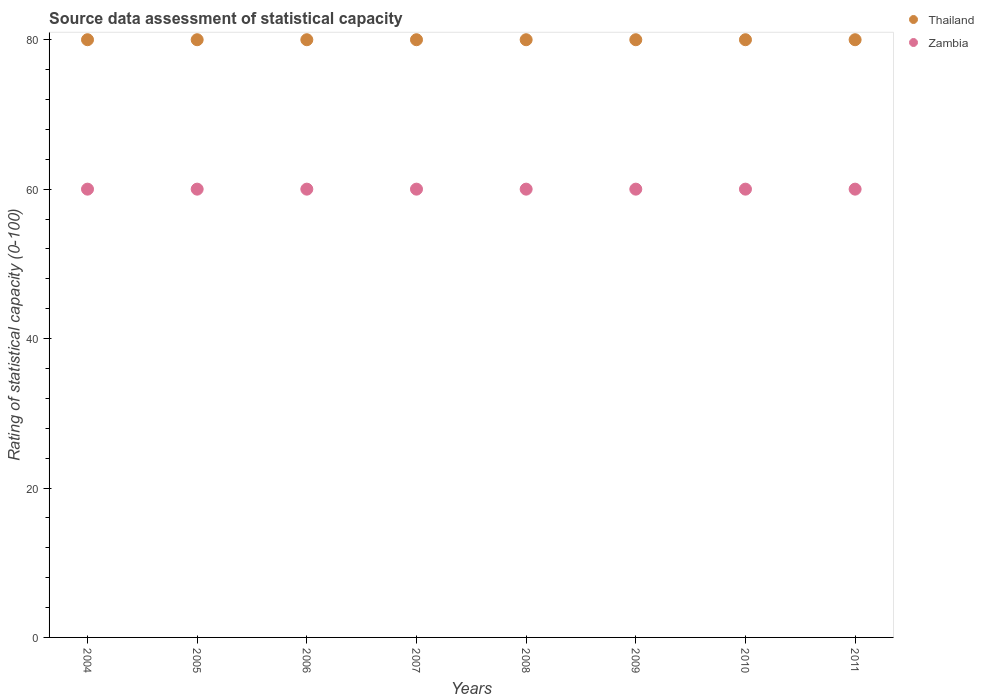Is the number of dotlines equal to the number of legend labels?
Keep it short and to the point. Yes. What is the rating of statistical capacity in Zambia in 2006?
Your answer should be compact. 60. Across all years, what is the maximum rating of statistical capacity in Thailand?
Your response must be concise. 80. Across all years, what is the minimum rating of statistical capacity in Thailand?
Your answer should be very brief. 80. What is the total rating of statistical capacity in Thailand in the graph?
Provide a succinct answer. 640. What is the difference between the rating of statistical capacity in Thailand in 2004 and the rating of statistical capacity in Zambia in 2008?
Ensure brevity in your answer.  20. In the year 2011, what is the difference between the rating of statistical capacity in Thailand and rating of statistical capacity in Zambia?
Provide a succinct answer. 20. Is the difference between the rating of statistical capacity in Thailand in 2009 and 2010 greater than the difference between the rating of statistical capacity in Zambia in 2009 and 2010?
Make the answer very short. No. Is the rating of statistical capacity in Zambia strictly greater than the rating of statistical capacity in Thailand over the years?
Your answer should be very brief. No. How many years are there in the graph?
Your answer should be very brief. 8. What is the difference between two consecutive major ticks on the Y-axis?
Keep it short and to the point. 20. Does the graph contain grids?
Your answer should be very brief. No. How are the legend labels stacked?
Your answer should be compact. Vertical. What is the title of the graph?
Provide a short and direct response. Source data assessment of statistical capacity. Does "Sub-Saharan Africa (developing only)" appear as one of the legend labels in the graph?
Keep it short and to the point. No. What is the label or title of the X-axis?
Make the answer very short. Years. What is the label or title of the Y-axis?
Make the answer very short. Rating of statistical capacity (0-100). What is the Rating of statistical capacity (0-100) in Zambia in 2005?
Your response must be concise. 60. What is the Rating of statistical capacity (0-100) in Zambia in 2007?
Ensure brevity in your answer.  60. What is the Rating of statistical capacity (0-100) in Thailand in 2009?
Your answer should be compact. 80. What is the Rating of statistical capacity (0-100) of Thailand in 2010?
Give a very brief answer. 80. What is the Rating of statistical capacity (0-100) in Zambia in 2010?
Keep it short and to the point. 60. Across all years, what is the maximum Rating of statistical capacity (0-100) of Zambia?
Give a very brief answer. 60. Across all years, what is the minimum Rating of statistical capacity (0-100) of Thailand?
Your answer should be very brief. 80. Across all years, what is the minimum Rating of statistical capacity (0-100) of Zambia?
Offer a terse response. 60. What is the total Rating of statistical capacity (0-100) in Thailand in the graph?
Provide a succinct answer. 640. What is the total Rating of statistical capacity (0-100) in Zambia in the graph?
Give a very brief answer. 480. What is the difference between the Rating of statistical capacity (0-100) of Thailand in 2004 and that in 2005?
Your answer should be very brief. 0. What is the difference between the Rating of statistical capacity (0-100) in Thailand in 2004 and that in 2006?
Your answer should be compact. 0. What is the difference between the Rating of statistical capacity (0-100) in Zambia in 2004 and that in 2006?
Provide a succinct answer. 0. What is the difference between the Rating of statistical capacity (0-100) in Thailand in 2004 and that in 2007?
Make the answer very short. 0. What is the difference between the Rating of statistical capacity (0-100) in Zambia in 2004 and that in 2007?
Offer a very short reply. 0. What is the difference between the Rating of statistical capacity (0-100) of Zambia in 2004 and that in 2008?
Provide a succinct answer. 0. What is the difference between the Rating of statistical capacity (0-100) in Thailand in 2004 and that in 2011?
Provide a short and direct response. 0. What is the difference between the Rating of statistical capacity (0-100) of Zambia in 2005 and that in 2007?
Your answer should be very brief. 0. What is the difference between the Rating of statistical capacity (0-100) in Zambia in 2005 and that in 2008?
Your answer should be compact. 0. What is the difference between the Rating of statistical capacity (0-100) in Thailand in 2005 and that in 2009?
Keep it short and to the point. 0. What is the difference between the Rating of statistical capacity (0-100) of Zambia in 2005 and that in 2010?
Offer a terse response. 0. What is the difference between the Rating of statistical capacity (0-100) of Thailand in 2006 and that in 2007?
Give a very brief answer. 0. What is the difference between the Rating of statistical capacity (0-100) of Zambia in 2006 and that in 2007?
Make the answer very short. 0. What is the difference between the Rating of statistical capacity (0-100) of Thailand in 2006 and that in 2008?
Give a very brief answer. 0. What is the difference between the Rating of statistical capacity (0-100) of Zambia in 2006 and that in 2008?
Your answer should be very brief. 0. What is the difference between the Rating of statistical capacity (0-100) of Thailand in 2006 and that in 2010?
Your answer should be compact. 0. What is the difference between the Rating of statistical capacity (0-100) of Zambia in 2006 and that in 2010?
Offer a terse response. 0. What is the difference between the Rating of statistical capacity (0-100) of Zambia in 2006 and that in 2011?
Ensure brevity in your answer.  0. What is the difference between the Rating of statistical capacity (0-100) of Thailand in 2007 and that in 2008?
Your answer should be very brief. 0. What is the difference between the Rating of statistical capacity (0-100) of Thailand in 2007 and that in 2009?
Your response must be concise. 0. What is the difference between the Rating of statistical capacity (0-100) of Thailand in 2007 and that in 2010?
Provide a short and direct response. 0. What is the difference between the Rating of statistical capacity (0-100) in Zambia in 2007 and that in 2010?
Provide a short and direct response. 0. What is the difference between the Rating of statistical capacity (0-100) of Thailand in 2008 and that in 2009?
Offer a terse response. 0. What is the difference between the Rating of statistical capacity (0-100) of Thailand in 2010 and that in 2011?
Provide a succinct answer. 0. What is the difference between the Rating of statistical capacity (0-100) in Zambia in 2010 and that in 2011?
Give a very brief answer. 0. What is the difference between the Rating of statistical capacity (0-100) in Thailand in 2004 and the Rating of statistical capacity (0-100) in Zambia in 2009?
Give a very brief answer. 20. What is the difference between the Rating of statistical capacity (0-100) of Thailand in 2004 and the Rating of statistical capacity (0-100) of Zambia in 2011?
Offer a very short reply. 20. What is the difference between the Rating of statistical capacity (0-100) of Thailand in 2005 and the Rating of statistical capacity (0-100) of Zambia in 2007?
Make the answer very short. 20. What is the difference between the Rating of statistical capacity (0-100) in Thailand in 2005 and the Rating of statistical capacity (0-100) in Zambia in 2009?
Keep it short and to the point. 20. What is the difference between the Rating of statistical capacity (0-100) in Thailand in 2005 and the Rating of statistical capacity (0-100) in Zambia in 2010?
Offer a terse response. 20. What is the difference between the Rating of statistical capacity (0-100) in Thailand in 2005 and the Rating of statistical capacity (0-100) in Zambia in 2011?
Provide a short and direct response. 20. What is the difference between the Rating of statistical capacity (0-100) in Thailand in 2007 and the Rating of statistical capacity (0-100) in Zambia in 2010?
Offer a very short reply. 20. What is the difference between the Rating of statistical capacity (0-100) of Thailand in 2007 and the Rating of statistical capacity (0-100) of Zambia in 2011?
Offer a terse response. 20. What is the difference between the Rating of statistical capacity (0-100) of Thailand in 2008 and the Rating of statistical capacity (0-100) of Zambia in 2010?
Give a very brief answer. 20. What is the difference between the Rating of statistical capacity (0-100) of Thailand in 2008 and the Rating of statistical capacity (0-100) of Zambia in 2011?
Your answer should be very brief. 20. What is the difference between the Rating of statistical capacity (0-100) of Thailand in 2009 and the Rating of statistical capacity (0-100) of Zambia in 2010?
Make the answer very short. 20. What is the difference between the Rating of statistical capacity (0-100) in Thailand in 2010 and the Rating of statistical capacity (0-100) in Zambia in 2011?
Keep it short and to the point. 20. What is the average Rating of statistical capacity (0-100) in Zambia per year?
Your response must be concise. 60. In the year 2004, what is the difference between the Rating of statistical capacity (0-100) in Thailand and Rating of statistical capacity (0-100) in Zambia?
Your answer should be compact. 20. In the year 2005, what is the difference between the Rating of statistical capacity (0-100) in Thailand and Rating of statistical capacity (0-100) in Zambia?
Make the answer very short. 20. In the year 2006, what is the difference between the Rating of statistical capacity (0-100) of Thailand and Rating of statistical capacity (0-100) of Zambia?
Give a very brief answer. 20. In the year 2007, what is the difference between the Rating of statistical capacity (0-100) in Thailand and Rating of statistical capacity (0-100) in Zambia?
Ensure brevity in your answer.  20. In the year 2009, what is the difference between the Rating of statistical capacity (0-100) in Thailand and Rating of statistical capacity (0-100) in Zambia?
Provide a short and direct response. 20. What is the ratio of the Rating of statistical capacity (0-100) of Thailand in 2004 to that in 2005?
Your answer should be very brief. 1. What is the ratio of the Rating of statistical capacity (0-100) of Zambia in 2004 to that in 2005?
Provide a short and direct response. 1. What is the ratio of the Rating of statistical capacity (0-100) of Thailand in 2004 to that in 2007?
Your response must be concise. 1. What is the ratio of the Rating of statistical capacity (0-100) in Zambia in 2004 to that in 2008?
Give a very brief answer. 1. What is the ratio of the Rating of statistical capacity (0-100) in Thailand in 2004 to that in 2009?
Offer a terse response. 1. What is the ratio of the Rating of statistical capacity (0-100) in Thailand in 2004 to that in 2011?
Offer a terse response. 1. What is the ratio of the Rating of statistical capacity (0-100) of Thailand in 2005 to that in 2006?
Make the answer very short. 1. What is the ratio of the Rating of statistical capacity (0-100) in Thailand in 2005 to that in 2007?
Your answer should be compact. 1. What is the ratio of the Rating of statistical capacity (0-100) of Zambia in 2005 to that in 2007?
Your answer should be compact. 1. What is the ratio of the Rating of statistical capacity (0-100) of Thailand in 2005 to that in 2008?
Provide a succinct answer. 1. What is the ratio of the Rating of statistical capacity (0-100) in Zambia in 2005 to that in 2008?
Your response must be concise. 1. What is the ratio of the Rating of statistical capacity (0-100) of Thailand in 2005 to that in 2009?
Make the answer very short. 1. What is the ratio of the Rating of statistical capacity (0-100) of Zambia in 2005 to that in 2011?
Ensure brevity in your answer.  1. What is the ratio of the Rating of statistical capacity (0-100) in Thailand in 2006 to that in 2010?
Keep it short and to the point. 1. What is the ratio of the Rating of statistical capacity (0-100) of Zambia in 2006 to that in 2010?
Your response must be concise. 1. What is the ratio of the Rating of statistical capacity (0-100) of Zambia in 2006 to that in 2011?
Your answer should be very brief. 1. What is the ratio of the Rating of statistical capacity (0-100) of Thailand in 2007 to that in 2009?
Provide a short and direct response. 1. What is the ratio of the Rating of statistical capacity (0-100) of Zambia in 2007 to that in 2009?
Provide a succinct answer. 1. What is the ratio of the Rating of statistical capacity (0-100) of Thailand in 2007 to that in 2010?
Keep it short and to the point. 1. What is the ratio of the Rating of statistical capacity (0-100) in Zambia in 2007 to that in 2010?
Provide a short and direct response. 1. What is the ratio of the Rating of statistical capacity (0-100) of Zambia in 2008 to that in 2009?
Make the answer very short. 1. What is the ratio of the Rating of statistical capacity (0-100) of Thailand in 2008 to that in 2010?
Keep it short and to the point. 1. What is the ratio of the Rating of statistical capacity (0-100) of Zambia in 2008 to that in 2011?
Ensure brevity in your answer.  1. What is the ratio of the Rating of statistical capacity (0-100) in Thailand in 2009 to that in 2010?
Offer a terse response. 1. What is the ratio of the Rating of statistical capacity (0-100) of Zambia in 2010 to that in 2011?
Make the answer very short. 1. What is the difference between the highest and the lowest Rating of statistical capacity (0-100) of Thailand?
Offer a terse response. 0. What is the difference between the highest and the lowest Rating of statistical capacity (0-100) of Zambia?
Give a very brief answer. 0. 